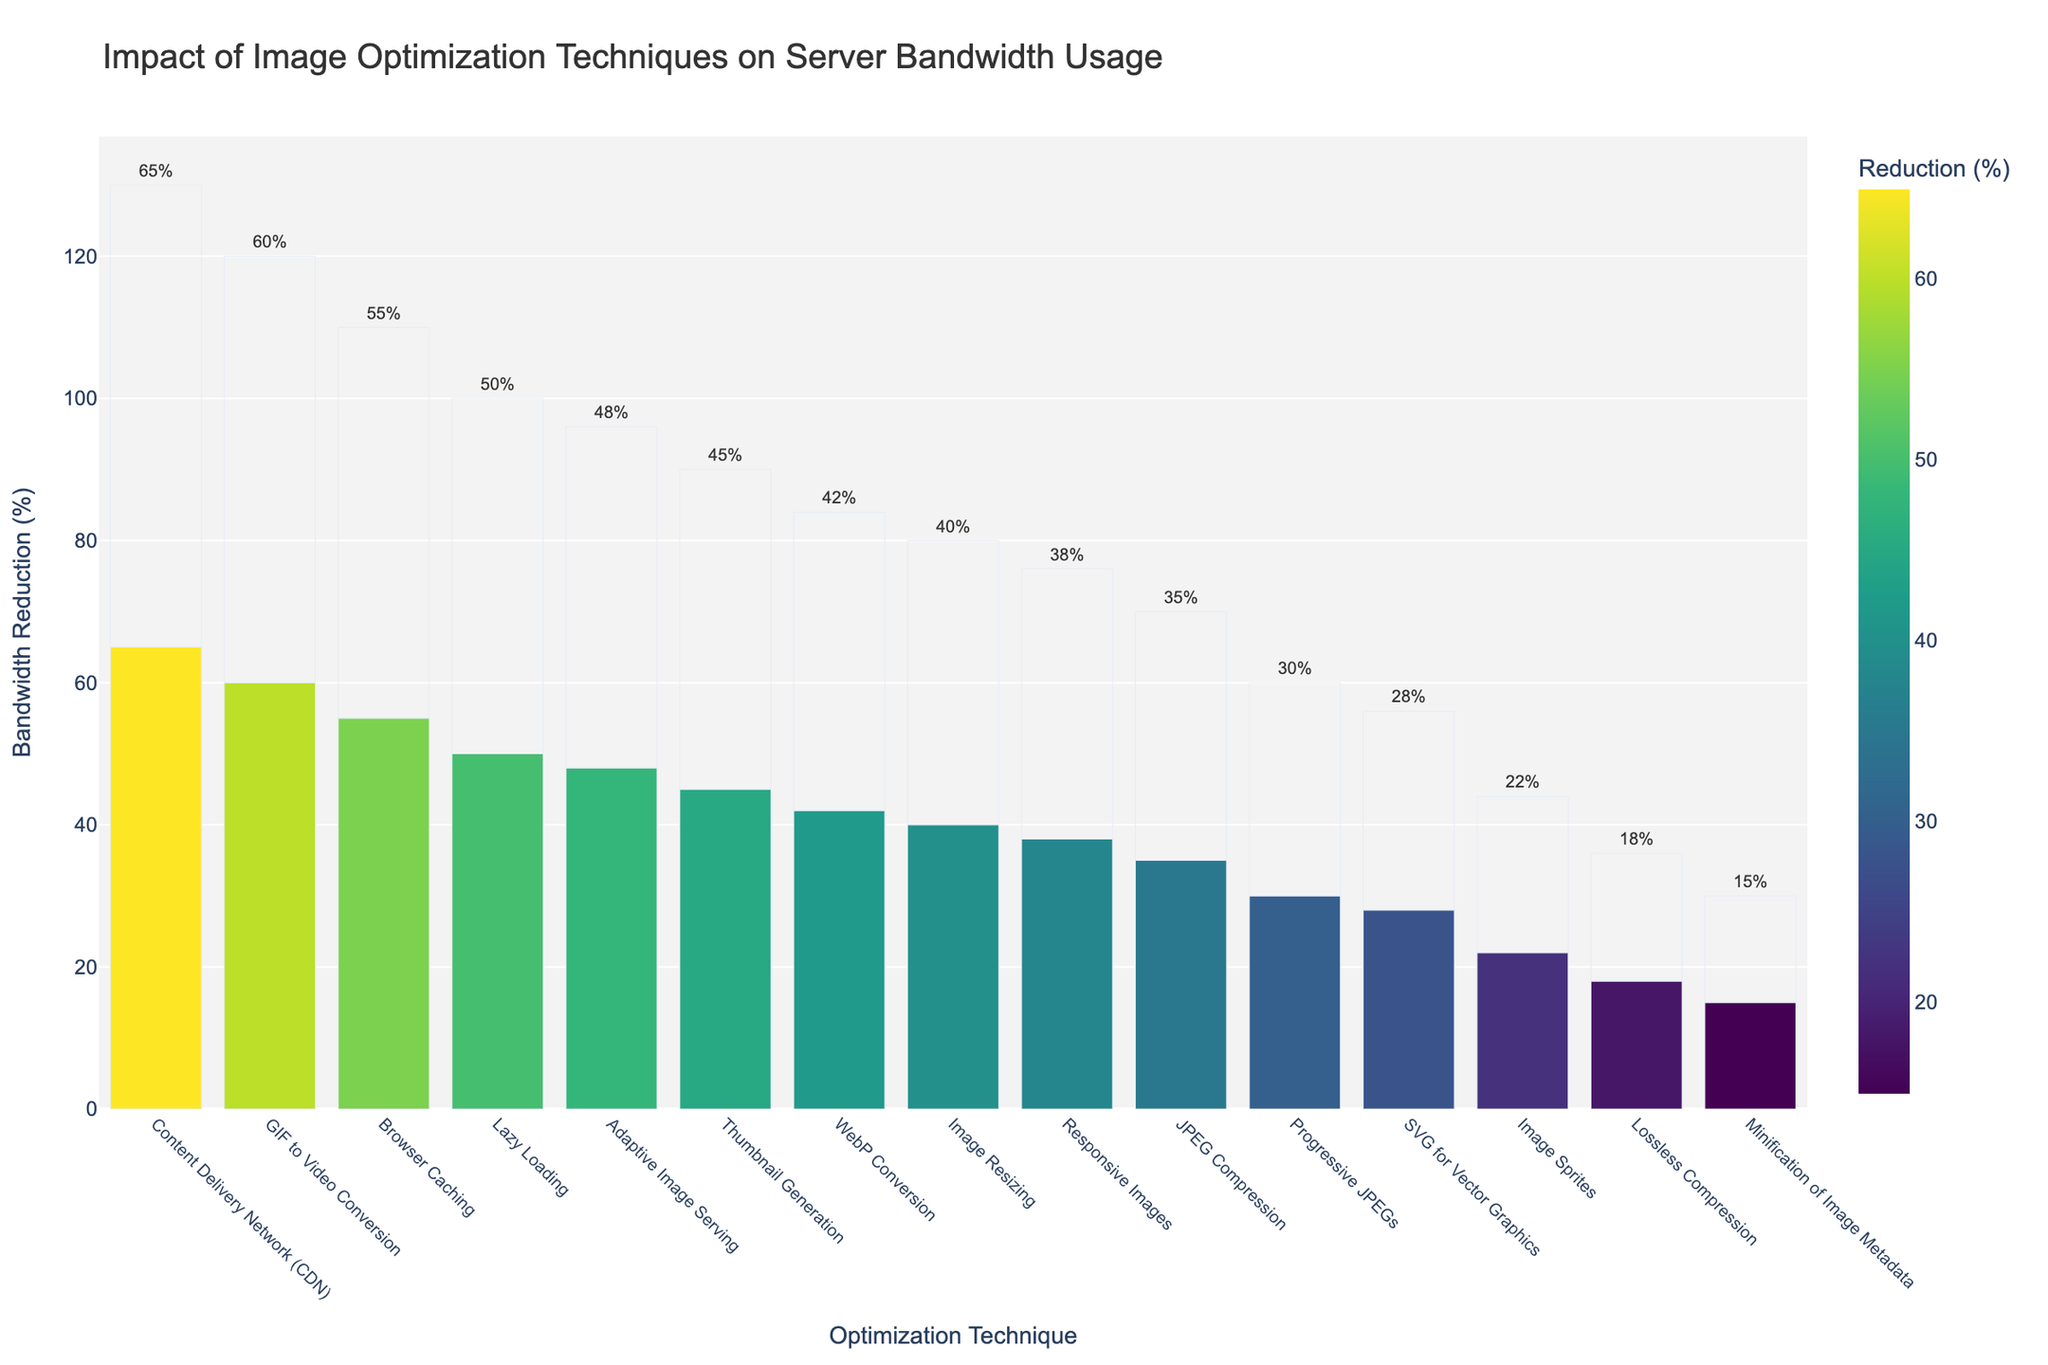What image optimization technique resulted in the highest bandwidth reduction? The bar chart shows the techniques sorted by bandwidth reduction in descending order. The technique at the top of the chart has the highest reduction.
Answer: Content Delivery Network (CDN) Which technique resulted in lower bandwidth reduction, JPEG Compression or Lossless Compression? Comparing the heights of the bars for JPEG Compression and Lossless Compression, JPEG Compression results in a higher bandwidth reduction.
Answer: Lossless Compression What is the difference in bandwidth reduction percentage between Adaptive Image Serving and Image Resizing? According to the chart, Adaptive Image Serving has 48% reduction and Image Resizing has 40%. Subtract Image Resizing's value from Adaptive Image Serving's.
Answer: 8% How many techniques resulted in a bandwidth reduction of more than 50%? Counting the bars with values greater than 50% on the chart shows three techniques.
Answer: 3 Which technique had the least impact on reducing bandwidth? The technique with the shortest bar on the chart represents the least bandwidth reduction.
Answer: Minification of Image Metadata Is the bandwidth reduction by Progressive JPEGs greater than the reduction by SVG for Vector Graphics? Comparing the heights of the bars for Progressive JPEGs and SVG for Vector Graphics, the bar for Progressive JPEGs is higher.
Answer: Yes What is the average bandwidth reduction percentage of the three techniques with the highest reductions? The three highest techniques are CDN (65%), GIF to Video Conversion (60%), and Browser Caching (55%). The sum of these percentages is 180%. Dividing by 3 gives an average.
Answer: 60% Arrange the techniques Lazy Loading, Thumbnail Generation, and WebP Conversion in descending order of bandwidth reduction. From the chart, Lazy Loading has 50%, Thumbnail Generation has 45%, and WebP Conversion has 42%. Arranging these from highest to lowest.
Answer: Lazy Loading, Thumbnail Generation, WebP Conversion What is the total combined bandwidth reduction percentage of all techniques listed? Summing all bandwidth reduction percentages from the chart: 35 + 42 + 28 + 50 + 65 + 38 + 22 + 30 + 45 + 18 + 55 + 40 + 60 + 48 + 15 = 591.
Answer: 591% Which technique shows a bandwidth reduction closest to 30%? The bar with the value closest to 30% is directly observed.
Answer: Progressive JPEGs 